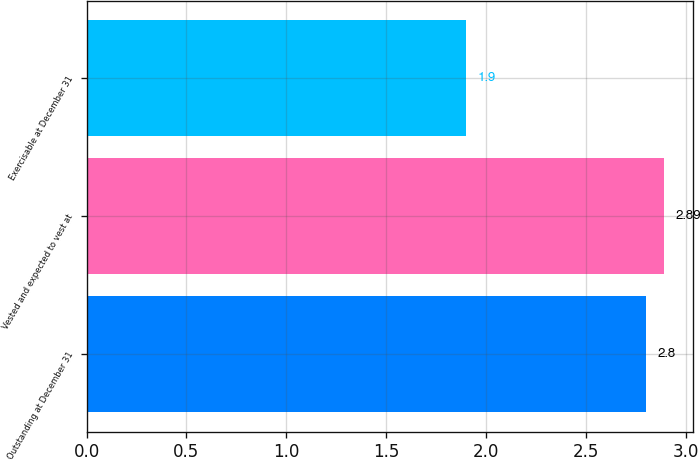Convert chart. <chart><loc_0><loc_0><loc_500><loc_500><bar_chart><fcel>Outstanding at December 31<fcel>Vested and expected to vest at<fcel>Exercisable at December 31<nl><fcel>2.8<fcel>2.89<fcel>1.9<nl></chart> 